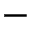<formula> <loc_0><loc_0><loc_500><loc_500>-</formula> 